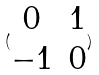<formula> <loc_0><loc_0><loc_500><loc_500>( \begin{matrix} 0 & 1 \\ - 1 & 0 \\ \end{matrix} )</formula> 